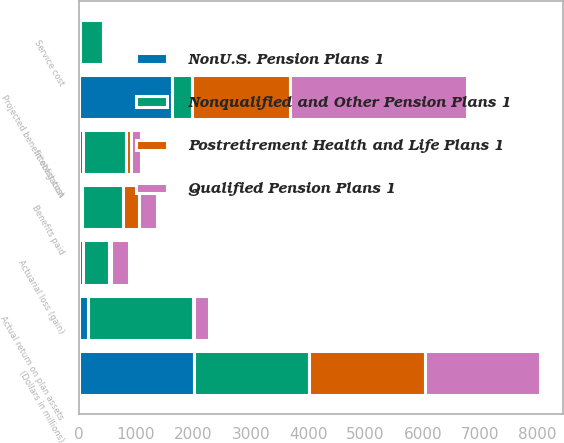Convert chart to OTSL. <chart><loc_0><loc_0><loc_500><loc_500><stacked_bar_chart><ecel><fcel>(Dollars in millions)<fcel>Actual return on plan assets<fcel>Benefits paid<fcel>Service cost<fcel>Interest cost<fcel>Actuarial loss (gain)<fcel>Projected benefit obligation<nl><fcel>Nonqualified and Other Pension Plans 1<fcel>2010<fcel>1835<fcel>714<fcel>397<fcel>748<fcel>459<fcel>355.5<nl><fcel>NonU.S. Pension Plans 1<fcel>2010<fcel>157<fcel>55<fcel>30<fcel>79<fcel>78<fcel>1624<nl><fcel>Qualified Pension Plans 1<fcel>2010<fcel>272<fcel>314<fcel>3<fcel>163<fcel>308<fcel>3078<nl><fcel>Postretirement Health and Life Plans 1<fcel>2010<fcel>13<fcel>275<fcel>14<fcel>92<fcel>32<fcel>1704<nl></chart> 